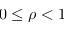Convert formula to latex. <formula><loc_0><loc_0><loc_500><loc_500>0 \leq \rho < 1</formula> 